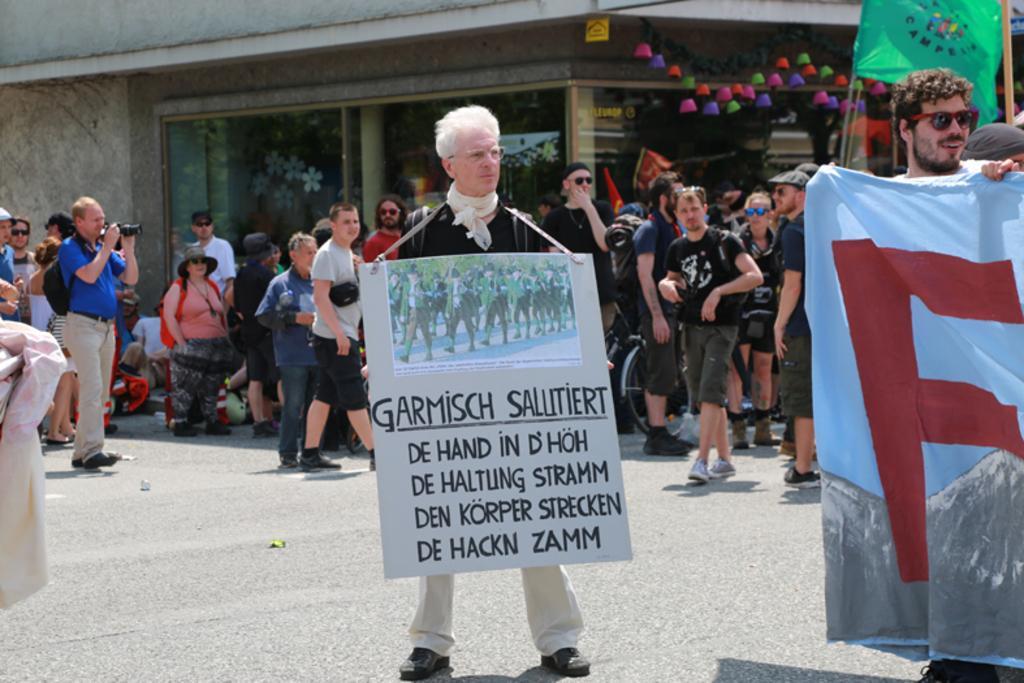How would you summarize this image in a sentence or two? In the foreground of this picture, there are persons holding a flag and board and standing on the road. In the background, there is the crowd standing in front of a building and few hangings to the buildings. 